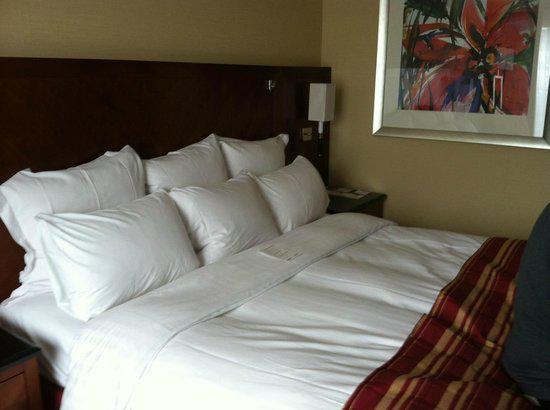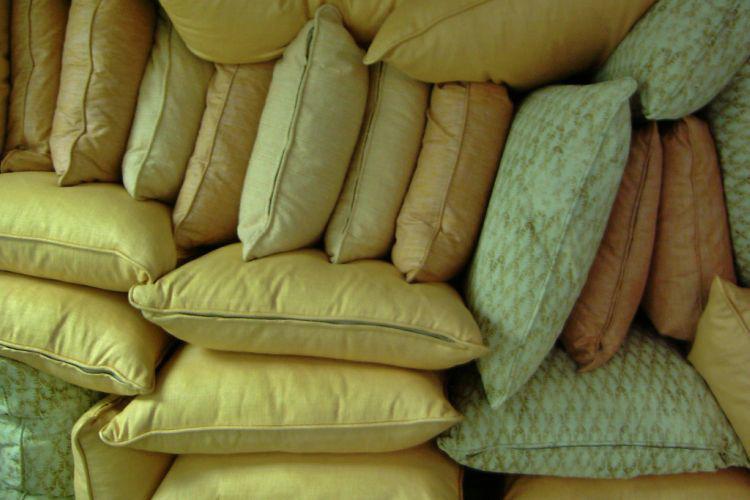The first image is the image on the left, the second image is the image on the right. Analyze the images presented: Is the assertion "An image shows pillows on a bed with a deep brown headboard." valid? Answer yes or no. Yes. 